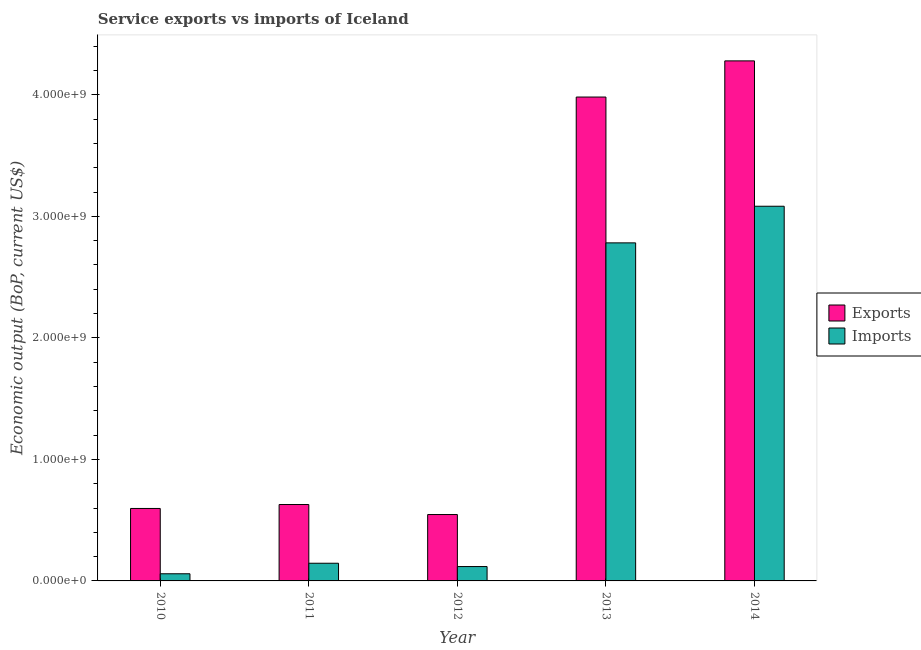How many different coloured bars are there?
Offer a terse response. 2. How many groups of bars are there?
Make the answer very short. 5. Are the number of bars per tick equal to the number of legend labels?
Your answer should be very brief. Yes. How many bars are there on the 3rd tick from the left?
Your answer should be compact. 2. What is the label of the 2nd group of bars from the left?
Your response must be concise. 2011. What is the amount of service imports in 2011?
Offer a very short reply. 1.45e+08. Across all years, what is the maximum amount of service imports?
Ensure brevity in your answer.  3.08e+09. Across all years, what is the minimum amount of service exports?
Your response must be concise. 5.46e+08. In which year was the amount of service exports maximum?
Offer a very short reply. 2014. What is the total amount of service imports in the graph?
Provide a short and direct response. 6.19e+09. What is the difference between the amount of service exports in 2011 and that in 2012?
Offer a terse response. 8.24e+07. What is the difference between the amount of service exports in 2011 and the amount of service imports in 2010?
Offer a very short reply. 3.24e+07. What is the average amount of service imports per year?
Your response must be concise. 1.24e+09. In the year 2011, what is the difference between the amount of service imports and amount of service exports?
Offer a terse response. 0. In how many years, is the amount of service imports greater than 3000000000 US$?
Ensure brevity in your answer.  1. What is the ratio of the amount of service exports in 2012 to that in 2014?
Your answer should be very brief. 0.13. What is the difference between the highest and the second highest amount of service exports?
Keep it short and to the point. 2.98e+08. What is the difference between the highest and the lowest amount of service imports?
Make the answer very short. 3.02e+09. What does the 2nd bar from the left in 2012 represents?
Keep it short and to the point. Imports. What does the 1st bar from the right in 2012 represents?
Keep it short and to the point. Imports. How many bars are there?
Your answer should be very brief. 10. Are all the bars in the graph horizontal?
Offer a terse response. No. How many years are there in the graph?
Ensure brevity in your answer.  5. Are the values on the major ticks of Y-axis written in scientific E-notation?
Keep it short and to the point. Yes. How are the legend labels stacked?
Provide a short and direct response. Vertical. What is the title of the graph?
Give a very brief answer. Service exports vs imports of Iceland. What is the label or title of the Y-axis?
Your answer should be compact. Economic output (BoP, current US$). What is the Economic output (BoP, current US$) in Exports in 2010?
Ensure brevity in your answer.  5.96e+08. What is the Economic output (BoP, current US$) in Imports in 2010?
Provide a succinct answer. 5.89e+07. What is the Economic output (BoP, current US$) in Exports in 2011?
Your response must be concise. 6.29e+08. What is the Economic output (BoP, current US$) of Imports in 2011?
Your answer should be very brief. 1.45e+08. What is the Economic output (BoP, current US$) in Exports in 2012?
Your answer should be compact. 5.46e+08. What is the Economic output (BoP, current US$) of Imports in 2012?
Offer a very short reply. 1.18e+08. What is the Economic output (BoP, current US$) of Exports in 2013?
Provide a succinct answer. 3.98e+09. What is the Economic output (BoP, current US$) in Imports in 2013?
Your answer should be compact. 2.78e+09. What is the Economic output (BoP, current US$) of Exports in 2014?
Offer a very short reply. 4.28e+09. What is the Economic output (BoP, current US$) of Imports in 2014?
Ensure brevity in your answer.  3.08e+09. Across all years, what is the maximum Economic output (BoP, current US$) in Exports?
Offer a terse response. 4.28e+09. Across all years, what is the maximum Economic output (BoP, current US$) of Imports?
Provide a short and direct response. 3.08e+09. Across all years, what is the minimum Economic output (BoP, current US$) of Exports?
Your answer should be very brief. 5.46e+08. Across all years, what is the minimum Economic output (BoP, current US$) of Imports?
Give a very brief answer. 5.89e+07. What is the total Economic output (BoP, current US$) in Exports in the graph?
Provide a short and direct response. 1.00e+1. What is the total Economic output (BoP, current US$) in Imports in the graph?
Provide a succinct answer. 6.19e+09. What is the difference between the Economic output (BoP, current US$) in Exports in 2010 and that in 2011?
Ensure brevity in your answer.  -3.24e+07. What is the difference between the Economic output (BoP, current US$) of Imports in 2010 and that in 2011?
Give a very brief answer. -8.66e+07. What is the difference between the Economic output (BoP, current US$) in Exports in 2010 and that in 2012?
Keep it short and to the point. 5.00e+07. What is the difference between the Economic output (BoP, current US$) of Imports in 2010 and that in 2012?
Your answer should be compact. -5.94e+07. What is the difference between the Economic output (BoP, current US$) of Exports in 2010 and that in 2013?
Keep it short and to the point. -3.39e+09. What is the difference between the Economic output (BoP, current US$) in Imports in 2010 and that in 2013?
Your answer should be compact. -2.72e+09. What is the difference between the Economic output (BoP, current US$) of Exports in 2010 and that in 2014?
Offer a terse response. -3.68e+09. What is the difference between the Economic output (BoP, current US$) in Imports in 2010 and that in 2014?
Your response must be concise. -3.02e+09. What is the difference between the Economic output (BoP, current US$) in Exports in 2011 and that in 2012?
Provide a succinct answer. 8.24e+07. What is the difference between the Economic output (BoP, current US$) of Imports in 2011 and that in 2012?
Offer a very short reply. 2.72e+07. What is the difference between the Economic output (BoP, current US$) of Exports in 2011 and that in 2013?
Your answer should be very brief. -3.35e+09. What is the difference between the Economic output (BoP, current US$) of Imports in 2011 and that in 2013?
Your answer should be very brief. -2.64e+09. What is the difference between the Economic output (BoP, current US$) in Exports in 2011 and that in 2014?
Give a very brief answer. -3.65e+09. What is the difference between the Economic output (BoP, current US$) of Imports in 2011 and that in 2014?
Offer a terse response. -2.94e+09. What is the difference between the Economic output (BoP, current US$) of Exports in 2012 and that in 2013?
Provide a succinct answer. -3.44e+09. What is the difference between the Economic output (BoP, current US$) of Imports in 2012 and that in 2013?
Your answer should be very brief. -2.66e+09. What is the difference between the Economic output (BoP, current US$) of Exports in 2012 and that in 2014?
Make the answer very short. -3.73e+09. What is the difference between the Economic output (BoP, current US$) in Imports in 2012 and that in 2014?
Give a very brief answer. -2.96e+09. What is the difference between the Economic output (BoP, current US$) in Exports in 2013 and that in 2014?
Ensure brevity in your answer.  -2.98e+08. What is the difference between the Economic output (BoP, current US$) of Imports in 2013 and that in 2014?
Your answer should be very brief. -3.01e+08. What is the difference between the Economic output (BoP, current US$) in Exports in 2010 and the Economic output (BoP, current US$) in Imports in 2011?
Ensure brevity in your answer.  4.51e+08. What is the difference between the Economic output (BoP, current US$) of Exports in 2010 and the Economic output (BoP, current US$) of Imports in 2012?
Give a very brief answer. 4.78e+08. What is the difference between the Economic output (BoP, current US$) of Exports in 2010 and the Economic output (BoP, current US$) of Imports in 2013?
Give a very brief answer. -2.19e+09. What is the difference between the Economic output (BoP, current US$) of Exports in 2010 and the Economic output (BoP, current US$) of Imports in 2014?
Offer a very short reply. -2.49e+09. What is the difference between the Economic output (BoP, current US$) in Exports in 2011 and the Economic output (BoP, current US$) in Imports in 2012?
Offer a terse response. 5.10e+08. What is the difference between the Economic output (BoP, current US$) of Exports in 2011 and the Economic output (BoP, current US$) of Imports in 2013?
Offer a terse response. -2.15e+09. What is the difference between the Economic output (BoP, current US$) in Exports in 2011 and the Economic output (BoP, current US$) in Imports in 2014?
Offer a terse response. -2.45e+09. What is the difference between the Economic output (BoP, current US$) of Exports in 2012 and the Economic output (BoP, current US$) of Imports in 2013?
Offer a terse response. -2.24e+09. What is the difference between the Economic output (BoP, current US$) of Exports in 2012 and the Economic output (BoP, current US$) of Imports in 2014?
Your response must be concise. -2.54e+09. What is the difference between the Economic output (BoP, current US$) of Exports in 2013 and the Economic output (BoP, current US$) of Imports in 2014?
Keep it short and to the point. 8.99e+08. What is the average Economic output (BoP, current US$) of Exports per year?
Offer a terse response. 2.01e+09. What is the average Economic output (BoP, current US$) of Imports per year?
Your answer should be very brief. 1.24e+09. In the year 2010, what is the difference between the Economic output (BoP, current US$) of Exports and Economic output (BoP, current US$) of Imports?
Make the answer very short. 5.37e+08. In the year 2011, what is the difference between the Economic output (BoP, current US$) in Exports and Economic output (BoP, current US$) in Imports?
Provide a short and direct response. 4.83e+08. In the year 2012, what is the difference between the Economic output (BoP, current US$) of Exports and Economic output (BoP, current US$) of Imports?
Your answer should be very brief. 4.28e+08. In the year 2013, what is the difference between the Economic output (BoP, current US$) of Exports and Economic output (BoP, current US$) of Imports?
Make the answer very short. 1.20e+09. In the year 2014, what is the difference between the Economic output (BoP, current US$) of Exports and Economic output (BoP, current US$) of Imports?
Provide a short and direct response. 1.20e+09. What is the ratio of the Economic output (BoP, current US$) in Exports in 2010 to that in 2011?
Your response must be concise. 0.95. What is the ratio of the Economic output (BoP, current US$) in Imports in 2010 to that in 2011?
Provide a succinct answer. 0.4. What is the ratio of the Economic output (BoP, current US$) of Exports in 2010 to that in 2012?
Give a very brief answer. 1.09. What is the ratio of the Economic output (BoP, current US$) of Imports in 2010 to that in 2012?
Provide a succinct answer. 0.5. What is the ratio of the Economic output (BoP, current US$) of Exports in 2010 to that in 2013?
Provide a short and direct response. 0.15. What is the ratio of the Economic output (BoP, current US$) of Imports in 2010 to that in 2013?
Provide a short and direct response. 0.02. What is the ratio of the Economic output (BoP, current US$) of Exports in 2010 to that in 2014?
Your answer should be compact. 0.14. What is the ratio of the Economic output (BoP, current US$) of Imports in 2010 to that in 2014?
Keep it short and to the point. 0.02. What is the ratio of the Economic output (BoP, current US$) of Exports in 2011 to that in 2012?
Provide a succinct answer. 1.15. What is the ratio of the Economic output (BoP, current US$) in Imports in 2011 to that in 2012?
Offer a very short reply. 1.23. What is the ratio of the Economic output (BoP, current US$) in Exports in 2011 to that in 2013?
Your answer should be compact. 0.16. What is the ratio of the Economic output (BoP, current US$) in Imports in 2011 to that in 2013?
Keep it short and to the point. 0.05. What is the ratio of the Economic output (BoP, current US$) of Exports in 2011 to that in 2014?
Give a very brief answer. 0.15. What is the ratio of the Economic output (BoP, current US$) of Imports in 2011 to that in 2014?
Offer a terse response. 0.05. What is the ratio of the Economic output (BoP, current US$) in Exports in 2012 to that in 2013?
Ensure brevity in your answer.  0.14. What is the ratio of the Economic output (BoP, current US$) of Imports in 2012 to that in 2013?
Your response must be concise. 0.04. What is the ratio of the Economic output (BoP, current US$) in Exports in 2012 to that in 2014?
Your answer should be very brief. 0.13. What is the ratio of the Economic output (BoP, current US$) of Imports in 2012 to that in 2014?
Your response must be concise. 0.04. What is the ratio of the Economic output (BoP, current US$) in Exports in 2013 to that in 2014?
Ensure brevity in your answer.  0.93. What is the ratio of the Economic output (BoP, current US$) in Imports in 2013 to that in 2014?
Provide a succinct answer. 0.9. What is the difference between the highest and the second highest Economic output (BoP, current US$) in Exports?
Provide a succinct answer. 2.98e+08. What is the difference between the highest and the second highest Economic output (BoP, current US$) in Imports?
Your answer should be compact. 3.01e+08. What is the difference between the highest and the lowest Economic output (BoP, current US$) of Exports?
Give a very brief answer. 3.73e+09. What is the difference between the highest and the lowest Economic output (BoP, current US$) of Imports?
Offer a terse response. 3.02e+09. 